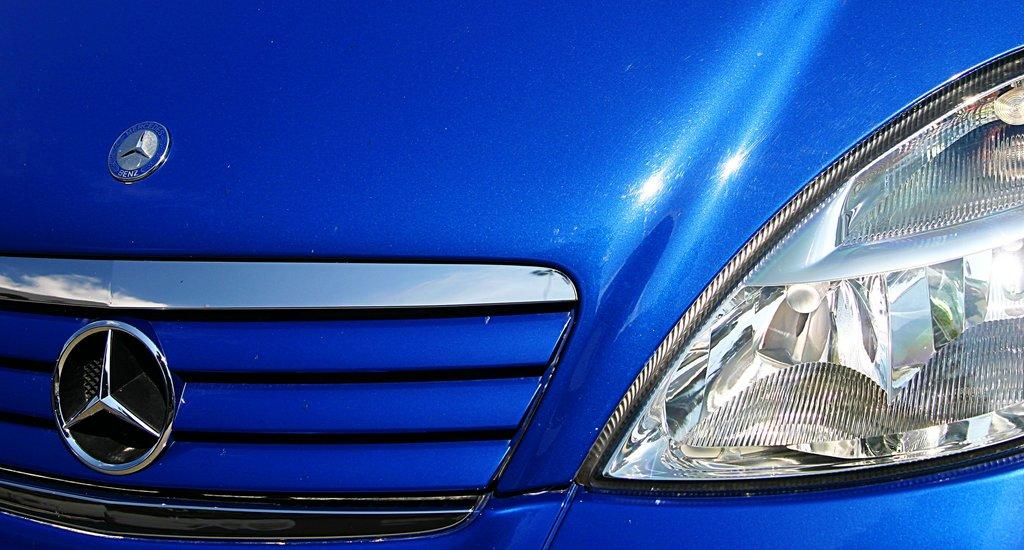What is the main subject of the image? The main subject of the image is a vehicle. What specific features can be seen on the vehicle? The vehicle has headlights and a logo. What type of popcorn is being served on the side of the vehicle in the image? There is no popcorn present in the image, and the vehicle does not have any food or snacks associated with it. 